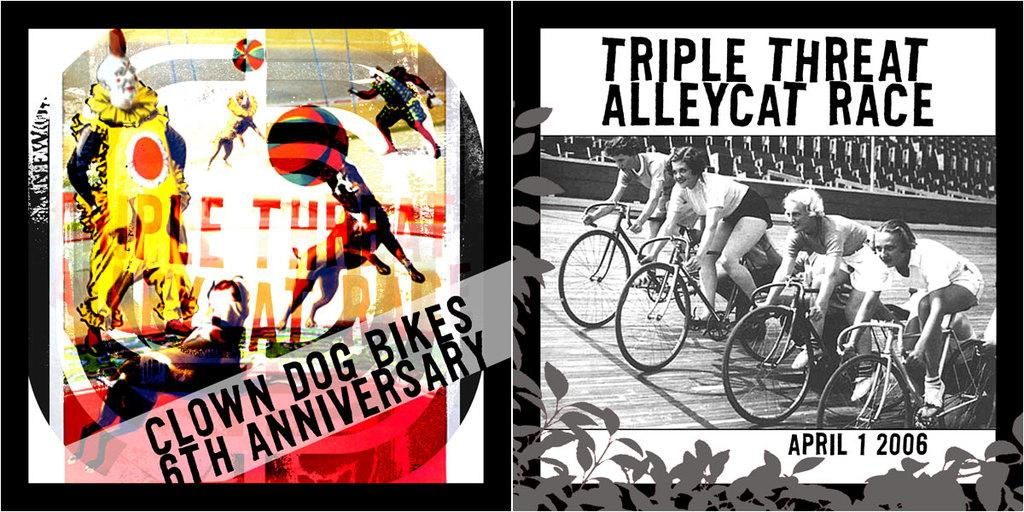<image>
Present a compact description of the photo's key features. a poster that says 'triple threat alleycat race' on it 